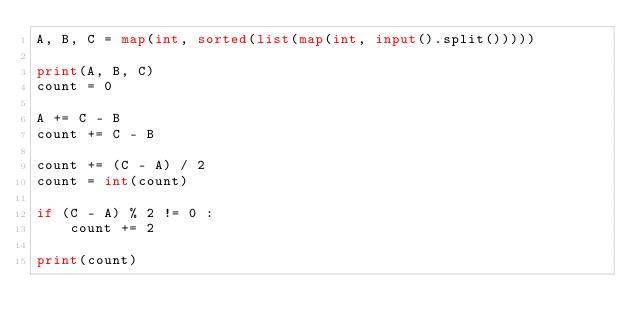<code> <loc_0><loc_0><loc_500><loc_500><_Python_>A, B, C = map(int, sorted(list(map(int, input().split()))))

print(A, B, C)
count = 0

A += C - B
count += C - B

count += (C - A) / 2
count = int(count)

if (C - A) % 2 != 0 :
    count += 2

print(count)
</code> 